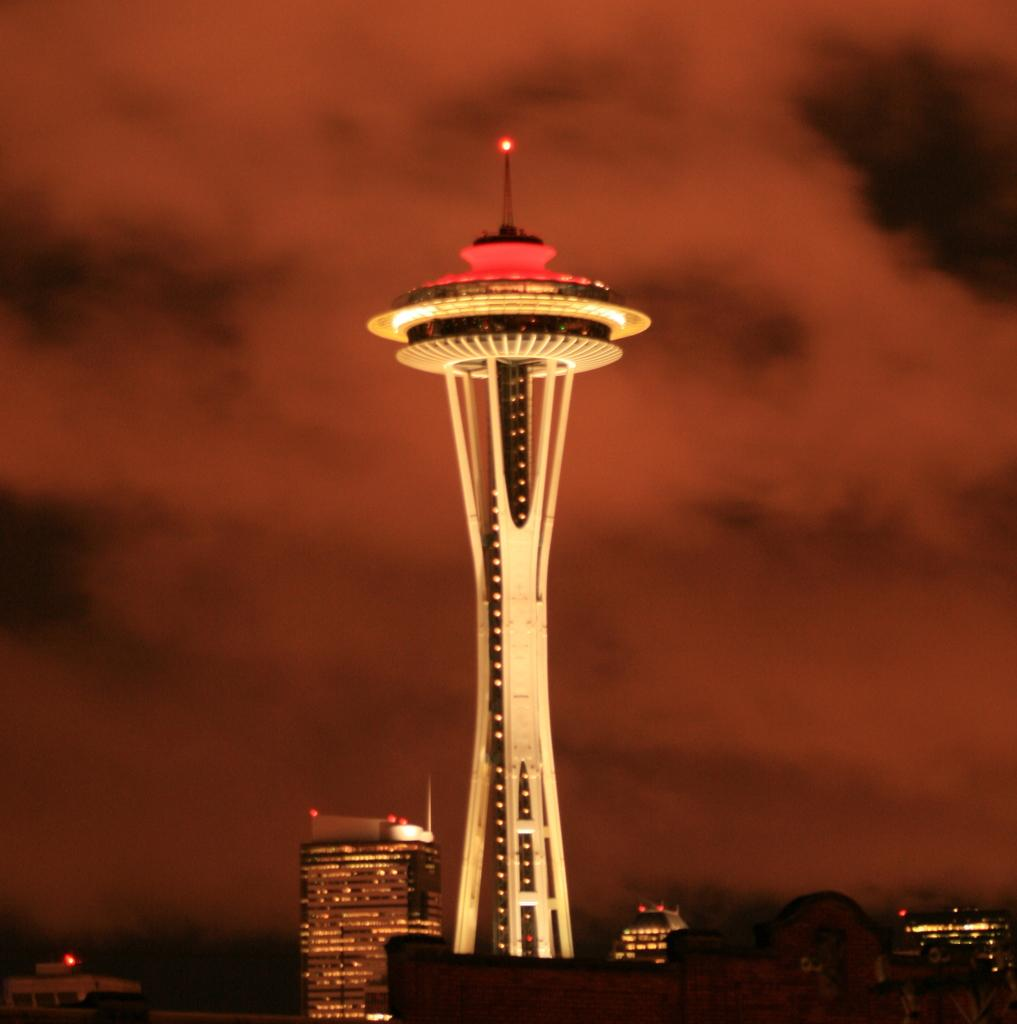What structures are located at the bottom of the image? There are buildings at the bottom of the image. What can be seen in the middle of the image? There is a tower in the middle of the image. What is visible in the background of the image? The sky is visible in the background of the image. Are there any umbrellas visible in the image? There are no umbrellas present in the image. What type of vegetation can be seen growing around the buildings in the image? The provided facts do not mention any vegetation, so we cannot determine if there is grass or any other type of vegetation in the image. Can you spot any snails crawling on the tower in the image? There are no snails present in the image. 